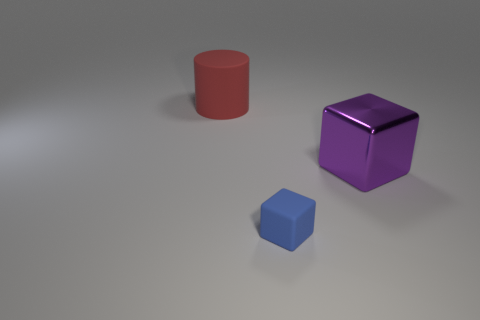Add 1 tiny blocks. How many objects exist? 4 Subtract all blocks. How many objects are left? 1 Add 2 tiny blue blocks. How many tiny blue blocks are left? 3 Add 3 tiny blue rubber blocks. How many tiny blue rubber blocks exist? 4 Subtract 0 blue cylinders. How many objects are left? 3 Subtract all small blue objects. Subtract all tiny blocks. How many objects are left? 1 